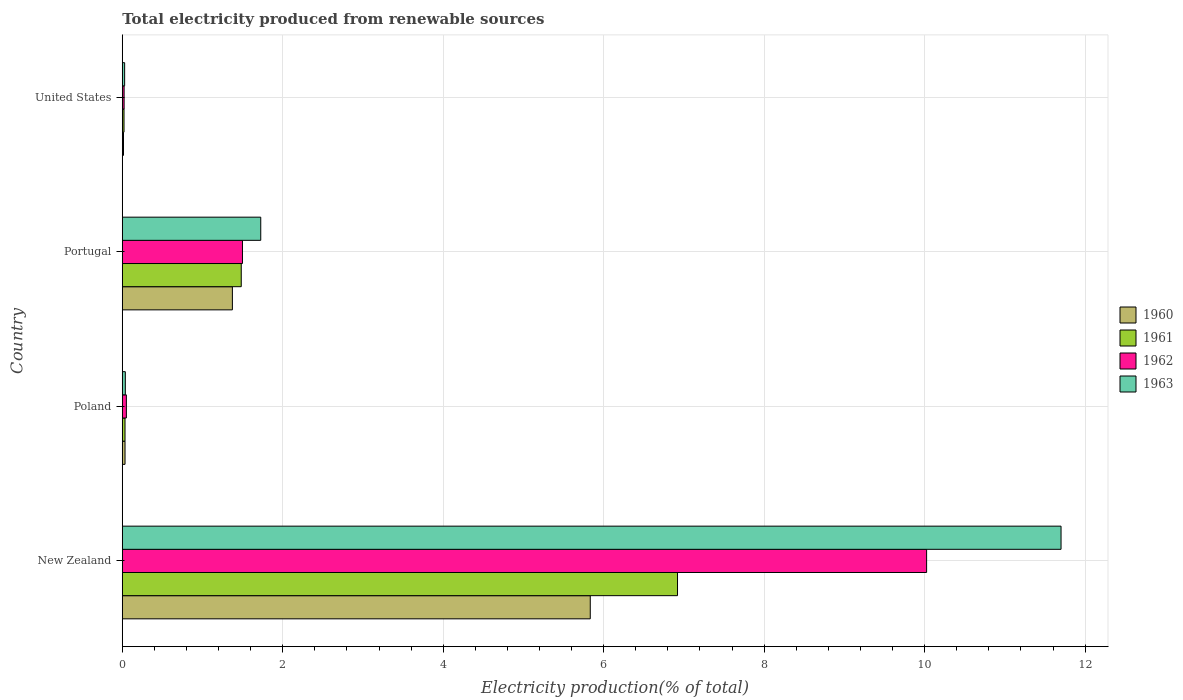How many different coloured bars are there?
Ensure brevity in your answer.  4. How many bars are there on the 1st tick from the top?
Your response must be concise. 4. What is the total electricity produced in 1961 in New Zealand?
Offer a terse response. 6.92. Across all countries, what is the maximum total electricity produced in 1962?
Offer a terse response. 10.02. Across all countries, what is the minimum total electricity produced in 1962?
Your answer should be compact. 0.02. In which country was the total electricity produced in 1963 maximum?
Your response must be concise. New Zealand. What is the total total electricity produced in 1962 in the graph?
Your answer should be compact. 11.6. What is the difference between the total electricity produced in 1960 in New Zealand and that in United States?
Give a very brief answer. 5.82. What is the difference between the total electricity produced in 1962 in Poland and the total electricity produced in 1960 in United States?
Your answer should be very brief. 0.04. What is the average total electricity produced in 1960 per country?
Your answer should be very brief. 1.81. What is the difference between the total electricity produced in 1960 and total electricity produced in 1963 in United States?
Make the answer very short. -0.01. In how many countries, is the total electricity produced in 1961 greater than 7.6 %?
Provide a succinct answer. 0. What is the ratio of the total electricity produced in 1960 in Poland to that in Portugal?
Keep it short and to the point. 0.02. Is the total electricity produced in 1962 in Portugal less than that in United States?
Make the answer very short. No. Is the difference between the total electricity produced in 1960 in Portugal and United States greater than the difference between the total electricity produced in 1963 in Portugal and United States?
Your answer should be very brief. No. What is the difference between the highest and the second highest total electricity produced in 1962?
Give a very brief answer. 8.53. What is the difference between the highest and the lowest total electricity produced in 1961?
Give a very brief answer. 6.9. In how many countries, is the total electricity produced in 1962 greater than the average total electricity produced in 1962 taken over all countries?
Your response must be concise. 1. Is the sum of the total electricity produced in 1963 in Poland and Portugal greater than the maximum total electricity produced in 1960 across all countries?
Ensure brevity in your answer.  No. Is it the case that in every country, the sum of the total electricity produced in 1962 and total electricity produced in 1960 is greater than the sum of total electricity produced in 1961 and total electricity produced in 1963?
Your answer should be very brief. No. What does the 3rd bar from the bottom in New Zealand represents?
Keep it short and to the point. 1962. How many bars are there?
Provide a succinct answer. 16. How many countries are there in the graph?
Your response must be concise. 4. Are the values on the major ticks of X-axis written in scientific E-notation?
Provide a succinct answer. No. Does the graph contain grids?
Your response must be concise. Yes. What is the title of the graph?
Offer a very short reply. Total electricity produced from renewable sources. Does "1970" appear as one of the legend labels in the graph?
Make the answer very short. No. What is the Electricity production(% of total) in 1960 in New Zealand?
Offer a very short reply. 5.83. What is the Electricity production(% of total) of 1961 in New Zealand?
Offer a terse response. 6.92. What is the Electricity production(% of total) of 1962 in New Zealand?
Keep it short and to the point. 10.02. What is the Electricity production(% of total) of 1963 in New Zealand?
Give a very brief answer. 11.7. What is the Electricity production(% of total) in 1960 in Poland?
Your response must be concise. 0.03. What is the Electricity production(% of total) in 1961 in Poland?
Your answer should be very brief. 0.03. What is the Electricity production(% of total) of 1962 in Poland?
Provide a succinct answer. 0.05. What is the Electricity production(% of total) of 1963 in Poland?
Give a very brief answer. 0.04. What is the Electricity production(% of total) of 1960 in Portugal?
Keep it short and to the point. 1.37. What is the Electricity production(% of total) of 1961 in Portugal?
Give a very brief answer. 1.48. What is the Electricity production(% of total) in 1962 in Portugal?
Your answer should be very brief. 1.5. What is the Electricity production(% of total) of 1963 in Portugal?
Ensure brevity in your answer.  1.73. What is the Electricity production(% of total) of 1960 in United States?
Provide a short and direct response. 0.02. What is the Electricity production(% of total) of 1961 in United States?
Your answer should be compact. 0.02. What is the Electricity production(% of total) of 1962 in United States?
Provide a succinct answer. 0.02. What is the Electricity production(% of total) of 1963 in United States?
Your response must be concise. 0.03. Across all countries, what is the maximum Electricity production(% of total) of 1960?
Give a very brief answer. 5.83. Across all countries, what is the maximum Electricity production(% of total) of 1961?
Keep it short and to the point. 6.92. Across all countries, what is the maximum Electricity production(% of total) of 1962?
Keep it short and to the point. 10.02. Across all countries, what is the maximum Electricity production(% of total) in 1963?
Provide a short and direct response. 11.7. Across all countries, what is the minimum Electricity production(% of total) in 1960?
Keep it short and to the point. 0.02. Across all countries, what is the minimum Electricity production(% of total) in 1961?
Ensure brevity in your answer.  0.02. Across all countries, what is the minimum Electricity production(% of total) of 1962?
Your answer should be very brief. 0.02. Across all countries, what is the minimum Electricity production(% of total) in 1963?
Provide a short and direct response. 0.03. What is the total Electricity production(% of total) of 1960 in the graph?
Give a very brief answer. 7.25. What is the total Electricity production(% of total) in 1961 in the graph?
Give a very brief answer. 8.46. What is the total Electricity production(% of total) of 1962 in the graph?
Offer a very short reply. 11.6. What is the total Electricity production(% of total) in 1963 in the graph?
Your answer should be very brief. 13.49. What is the difference between the Electricity production(% of total) in 1960 in New Zealand and that in Poland?
Your response must be concise. 5.8. What is the difference between the Electricity production(% of total) of 1961 in New Zealand and that in Poland?
Offer a very short reply. 6.89. What is the difference between the Electricity production(% of total) of 1962 in New Zealand and that in Poland?
Keep it short and to the point. 9.97. What is the difference between the Electricity production(% of total) of 1963 in New Zealand and that in Poland?
Offer a terse response. 11.66. What is the difference between the Electricity production(% of total) of 1960 in New Zealand and that in Portugal?
Your answer should be compact. 4.46. What is the difference between the Electricity production(% of total) in 1961 in New Zealand and that in Portugal?
Give a very brief answer. 5.44. What is the difference between the Electricity production(% of total) in 1962 in New Zealand and that in Portugal?
Offer a very short reply. 8.53. What is the difference between the Electricity production(% of total) in 1963 in New Zealand and that in Portugal?
Make the answer very short. 9.97. What is the difference between the Electricity production(% of total) in 1960 in New Zealand and that in United States?
Keep it short and to the point. 5.82. What is the difference between the Electricity production(% of total) in 1961 in New Zealand and that in United States?
Your answer should be compact. 6.9. What is the difference between the Electricity production(% of total) in 1962 in New Zealand and that in United States?
Give a very brief answer. 10. What is the difference between the Electricity production(% of total) of 1963 in New Zealand and that in United States?
Provide a short and direct response. 11.67. What is the difference between the Electricity production(% of total) of 1960 in Poland and that in Portugal?
Provide a succinct answer. -1.34. What is the difference between the Electricity production(% of total) of 1961 in Poland and that in Portugal?
Provide a succinct answer. -1.45. What is the difference between the Electricity production(% of total) of 1962 in Poland and that in Portugal?
Provide a short and direct response. -1.45. What is the difference between the Electricity production(% of total) of 1963 in Poland and that in Portugal?
Give a very brief answer. -1.69. What is the difference between the Electricity production(% of total) of 1960 in Poland and that in United States?
Make the answer very short. 0.02. What is the difference between the Electricity production(% of total) of 1961 in Poland and that in United States?
Offer a terse response. 0.01. What is the difference between the Electricity production(% of total) in 1962 in Poland and that in United States?
Make the answer very short. 0.03. What is the difference between the Electricity production(% of total) of 1963 in Poland and that in United States?
Ensure brevity in your answer.  0.01. What is the difference between the Electricity production(% of total) of 1960 in Portugal and that in United States?
Your response must be concise. 1.36. What is the difference between the Electricity production(% of total) of 1961 in Portugal and that in United States?
Provide a succinct answer. 1.46. What is the difference between the Electricity production(% of total) of 1962 in Portugal and that in United States?
Your answer should be very brief. 1.48. What is the difference between the Electricity production(% of total) in 1963 in Portugal and that in United States?
Give a very brief answer. 1.7. What is the difference between the Electricity production(% of total) in 1960 in New Zealand and the Electricity production(% of total) in 1961 in Poland?
Your response must be concise. 5.8. What is the difference between the Electricity production(% of total) in 1960 in New Zealand and the Electricity production(% of total) in 1962 in Poland?
Your response must be concise. 5.78. What is the difference between the Electricity production(% of total) in 1960 in New Zealand and the Electricity production(% of total) in 1963 in Poland?
Offer a terse response. 5.79. What is the difference between the Electricity production(% of total) in 1961 in New Zealand and the Electricity production(% of total) in 1962 in Poland?
Your answer should be very brief. 6.87. What is the difference between the Electricity production(% of total) in 1961 in New Zealand and the Electricity production(% of total) in 1963 in Poland?
Give a very brief answer. 6.88. What is the difference between the Electricity production(% of total) in 1962 in New Zealand and the Electricity production(% of total) in 1963 in Poland?
Offer a very short reply. 9.99. What is the difference between the Electricity production(% of total) of 1960 in New Zealand and the Electricity production(% of total) of 1961 in Portugal?
Provide a short and direct response. 4.35. What is the difference between the Electricity production(% of total) of 1960 in New Zealand and the Electricity production(% of total) of 1962 in Portugal?
Your response must be concise. 4.33. What is the difference between the Electricity production(% of total) of 1960 in New Zealand and the Electricity production(% of total) of 1963 in Portugal?
Offer a very short reply. 4.11. What is the difference between the Electricity production(% of total) of 1961 in New Zealand and the Electricity production(% of total) of 1962 in Portugal?
Offer a terse response. 5.42. What is the difference between the Electricity production(% of total) of 1961 in New Zealand and the Electricity production(% of total) of 1963 in Portugal?
Give a very brief answer. 5.19. What is the difference between the Electricity production(% of total) in 1962 in New Zealand and the Electricity production(% of total) in 1963 in Portugal?
Your response must be concise. 8.3. What is the difference between the Electricity production(% of total) of 1960 in New Zealand and the Electricity production(% of total) of 1961 in United States?
Your response must be concise. 5.81. What is the difference between the Electricity production(% of total) of 1960 in New Zealand and the Electricity production(% of total) of 1962 in United States?
Provide a succinct answer. 5.81. What is the difference between the Electricity production(% of total) of 1960 in New Zealand and the Electricity production(% of total) of 1963 in United States?
Give a very brief answer. 5.8. What is the difference between the Electricity production(% of total) in 1961 in New Zealand and the Electricity production(% of total) in 1962 in United States?
Keep it short and to the point. 6.9. What is the difference between the Electricity production(% of total) in 1961 in New Zealand and the Electricity production(% of total) in 1963 in United States?
Offer a very short reply. 6.89. What is the difference between the Electricity production(% of total) in 1962 in New Zealand and the Electricity production(% of total) in 1963 in United States?
Provide a short and direct response. 10. What is the difference between the Electricity production(% of total) of 1960 in Poland and the Electricity production(% of total) of 1961 in Portugal?
Your response must be concise. -1.45. What is the difference between the Electricity production(% of total) of 1960 in Poland and the Electricity production(% of total) of 1962 in Portugal?
Your response must be concise. -1.46. What is the difference between the Electricity production(% of total) in 1960 in Poland and the Electricity production(% of total) in 1963 in Portugal?
Ensure brevity in your answer.  -1.69. What is the difference between the Electricity production(% of total) of 1961 in Poland and the Electricity production(% of total) of 1962 in Portugal?
Give a very brief answer. -1.46. What is the difference between the Electricity production(% of total) in 1961 in Poland and the Electricity production(% of total) in 1963 in Portugal?
Give a very brief answer. -1.69. What is the difference between the Electricity production(% of total) in 1962 in Poland and the Electricity production(% of total) in 1963 in Portugal?
Your response must be concise. -1.67. What is the difference between the Electricity production(% of total) of 1960 in Poland and the Electricity production(% of total) of 1961 in United States?
Provide a short and direct response. 0.01. What is the difference between the Electricity production(% of total) of 1960 in Poland and the Electricity production(% of total) of 1962 in United States?
Keep it short and to the point. 0.01. What is the difference between the Electricity production(% of total) of 1960 in Poland and the Electricity production(% of total) of 1963 in United States?
Your answer should be very brief. 0. What is the difference between the Electricity production(% of total) in 1961 in Poland and the Electricity production(% of total) in 1962 in United States?
Your answer should be very brief. 0.01. What is the difference between the Electricity production(% of total) of 1961 in Poland and the Electricity production(% of total) of 1963 in United States?
Your answer should be compact. 0. What is the difference between the Electricity production(% of total) of 1962 in Poland and the Electricity production(% of total) of 1963 in United States?
Make the answer very short. 0.02. What is the difference between the Electricity production(% of total) in 1960 in Portugal and the Electricity production(% of total) in 1961 in United States?
Keep it short and to the point. 1.35. What is the difference between the Electricity production(% of total) of 1960 in Portugal and the Electricity production(% of total) of 1962 in United States?
Give a very brief answer. 1.35. What is the difference between the Electricity production(% of total) in 1960 in Portugal and the Electricity production(% of total) in 1963 in United States?
Your answer should be compact. 1.34. What is the difference between the Electricity production(% of total) of 1961 in Portugal and the Electricity production(% of total) of 1962 in United States?
Provide a succinct answer. 1.46. What is the difference between the Electricity production(% of total) in 1961 in Portugal and the Electricity production(% of total) in 1963 in United States?
Give a very brief answer. 1.45. What is the difference between the Electricity production(% of total) in 1962 in Portugal and the Electricity production(% of total) in 1963 in United States?
Give a very brief answer. 1.47. What is the average Electricity production(% of total) in 1960 per country?
Keep it short and to the point. 1.81. What is the average Electricity production(% of total) of 1961 per country?
Ensure brevity in your answer.  2.11. What is the average Electricity production(% of total) in 1962 per country?
Provide a short and direct response. 2.9. What is the average Electricity production(% of total) in 1963 per country?
Keep it short and to the point. 3.37. What is the difference between the Electricity production(% of total) of 1960 and Electricity production(% of total) of 1961 in New Zealand?
Your answer should be very brief. -1.09. What is the difference between the Electricity production(% of total) of 1960 and Electricity production(% of total) of 1962 in New Zealand?
Make the answer very short. -4.19. What is the difference between the Electricity production(% of total) of 1960 and Electricity production(% of total) of 1963 in New Zealand?
Offer a very short reply. -5.87. What is the difference between the Electricity production(% of total) of 1961 and Electricity production(% of total) of 1962 in New Zealand?
Make the answer very short. -3.1. What is the difference between the Electricity production(% of total) of 1961 and Electricity production(% of total) of 1963 in New Zealand?
Provide a short and direct response. -4.78. What is the difference between the Electricity production(% of total) of 1962 and Electricity production(% of total) of 1963 in New Zealand?
Give a very brief answer. -1.68. What is the difference between the Electricity production(% of total) in 1960 and Electricity production(% of total) in 1961 in Poland?
Provide a succinct answer. 0. What is the difference between the Electricity production(% of total) of 1960 and Electricity production(% of total) of 1962 in Poland?
Keep it short and to the point. -0.02. What is the difference between the Electricity production(% of total) in 1960 and Electricity production(% of total) in 1963 in Poland?
Ensure brevity in your answer.  -0. What is the difference between the Electricity production(% of total) of 1961 and Electricity production(% of total) of 1962 in Poland?
Provide a succinct answer. -0.02. What is the difference between the Electricity production(% of total) of 1961 and Electricity production(% of total) of 1963 in Poland?
Provide a short and direct response. -0. What is the difference between the Electricity production(% of total) of 1962 and Electricity production(% of total) of 1963 in Poland?
Ensure brevity in your answer.  0.01. What is the difference between the Electricity production(% of total) of 1960 and Electricity production(% of total) of 1961 in Portugal?
Your answer should be very brief. -0.11. What is the difference between the Electricity production(% of total) of 1960 and Electricity production(% of total) of 1962 in Portugal?
Give a very brief answer. -0.13. What is the difference between the Electricity production(% of total) of 1960 and Electricity production(% of total) of 1963 in Portugal?
Make the answer very short. -0.35. What is the difference between the Electricity production(% of total) in 1961 and Electricity production(% of total) in 1962 in Portugal?
Offer a very short reply. -0.02. What is the difference between the Electricity production(% of total) in 1961 and Electricity production(% of total) in 1963 in Portugal?
Offer a terse response. -0.24. What is the difference between the Electricity production(% of total) in 1962 and Electricity production(% of total) in 1963 in Portugal?
Offer a very short reply. -0.23. What is the difference between the Electricity production(% of total) in 1960 and Electricity production(% of total) in 1961 in United States?
Offer a very short reply. -0.01. What is the difference between the Electricity production(% of total) of 1960 and Electricity production(% of total) of 1962 in United States?
Your answer should be compact. -0.01. What is the difference between the Electricity production(% of total) of 1960 and Electricity production(% of total) of 1963 in United States?
Give a very brief answer. -0.01. What is the difference between the Electricity production(% of total) in 1961 and Electricity production(% of total) in 1962 in United States?
Keep it short and to the point. -0. What is the difference between the Electricity production(% of total) in 1961 and Electricity production(% of total) in 1963 in United States?
Ensure brevity in your answer.  -0.01. What is the difference between the Electricity production(% of total) in 1962 and Electricity production(% of total) in 1963 in United States?
Offer a very short reply. -0.01. What is the ratio of the Electricity production(% of total) in 1960 in New Zealand to that in Poland?
Make the answer very short. 170.79. What is the ratio of the Electricity production(% of total) in 1961 in New Zealand to that in Poland?
Keep it short and to the point. 202.83. What is the ratio of the Electricity production(% of total) in 1962 in New Zealand to that in Poland?
Your answer should be compact. 196.95. What is the ratio of the Electricity production(% of total) of 1963 in New Zealand to that in Poland?
Give a very brief answer. 308.73. What is the ratio of the Electricity production(% of total) in 1960 in New Zealand to that in Portugal?
Your response must be concise. 4.25. What is the ratio of the Electricity production(% of total) in 1961 in New Zealand to that in Portugal?
Ensure brevity in your answer.  4.67. What is the ratio of the Electricity production(% of total) in 1962 in New Zealand to that in Portugal?
Give a very brief answer. 6.69. What is the ratio of the Electricity production(% of total) of 1963 in New Zealand to that in Portugal?
Give a very brief answer. 6.78. What is the ratio of the Electricity production(% of total) of 1960 in New Zealand to that in United States?
Your answer should be compact. 382.31. What is the ratio of the Electricity production(% of total) of 1961 in New Zealand to that in United States?
Offer a terse response. 321.25. What is the ratio of the Electricity production(% of total) of 1962 in New Zealand to that in United States?
Give a very brief answer. 439.93. What is the ratio of the Electricity production(% of total) of 1963 in New Zealand to that in United States?
Your answer should be compact. 397.5. What is the ratio of the Electricity production(% of total) in 1960 in Poland to that in Portugal?
Keep it short and to the point. 0.02. What is the ratio of the Electricity production(% of total) in 1961 in Poland to that in Portugal?
Ensure brevity in your answer.  0.02. What is the ratio of the Electricity production(% of total) of 1962 in Poland to that in Portugal?
Keep it short and to the point. 0.03. What is the ratio of the Electricity production(% of total) in 1963 in Poland to that in Portugal?
Offer a terse response. 0.02. What is the ratio of the Electricity production(% of total) in 1960 in Poland to that in United States?
Give a very brief answer. 2.24. What is the ratio of the Electricity production(% of total) of 1961 in Poland to that in United States?
Make the answer very short. 1.58. What is the ratio of the Electricity production(% of total) in 1962 in Poland to that in United States?
Offer a very short reply. 2.23. What is the ratio of the Electricity production(% of total) of 1963 in Poland to that in United States?
Offer a very short reply. 1.29. What is the ratio of the Electricity production(% of total) in 1960 in Portugal to that in United States?
Keep it short and to the point. 89.96. What is the ratio of the Electricity production(% of total) in 1961 in Portugal to that in United States?
Make the answer very short. 68.83. What is the ratio of the Electricity production(% of total) in 1962 in Portugal to that in United States?
Provide a short and direct response. 65.74. What is the ratio of the Electricity production(% of total) of 1963 in Portugal to that in United States?
Offer a very short reply. 58.63. What is the difference between the highest and the second highest Electricity production(% of total) of 1960?
Give a very brief answer. 4.46. What is the difference between the highest and the second highest Electricity production(% of total) of 1961?
Provide a short and direct response. 5.44. What is the difference between the highest and the second highest Electricity production(% of total) in 1962?
Make the answer very short. 8.53. What is the difference between the highest and the second highest Electricity production(% of total) in 1963?
Provide a short and direct response. 9.97. What is the difference between the highest and the lowest Electricity production(% of total) in 1960?
Keep it short and to the point. 5.82. What is the difference between the highest and the lowest Electricity production(% of total) in 1961?
Offer a terse response. 6.9. What is the difference between the highest and the lowest Electricity production(% of total) of 1962?
Provide a short and direct response. 10. What is the difference between the highest and the lowest Electricity production(% of total) of 1963?
Make the answer very short. 11.67. 